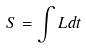<formula> <loc_0><loc_0><loc_500><loc_500>S = \int L d t</formula> 